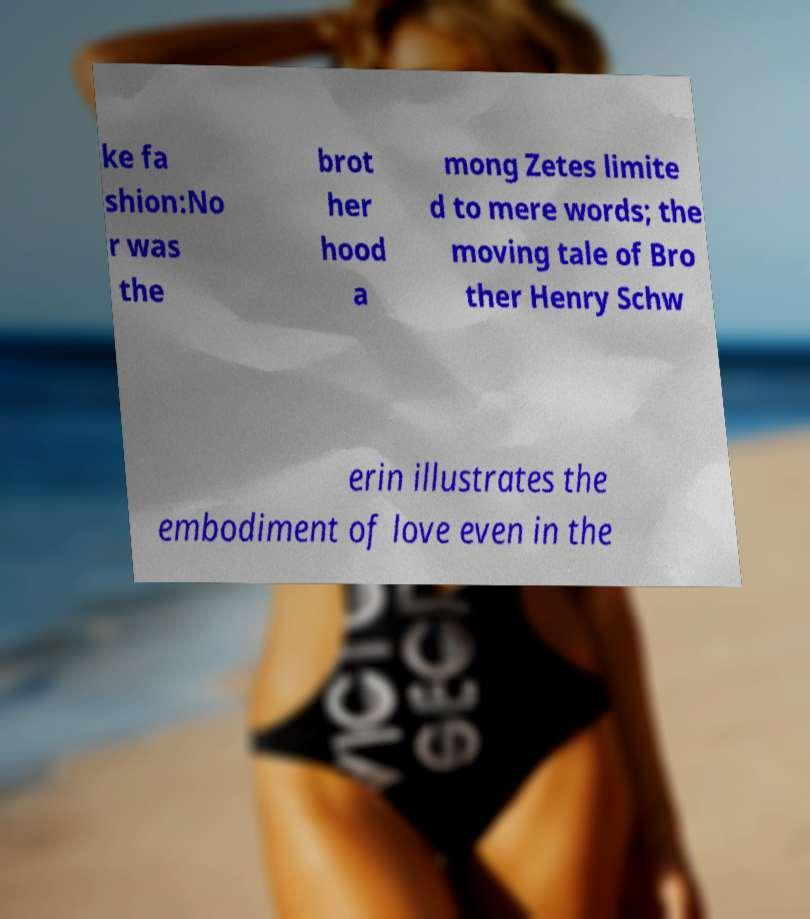For documentation purposes, I need the text within this image transcribed. Could you provide that? ke fa shion:No r was the brot her hood a mong Zetes limite d to mere words; the moving tale of Bro ther Henry Schw erin illustrates the embodiment of love even in the 